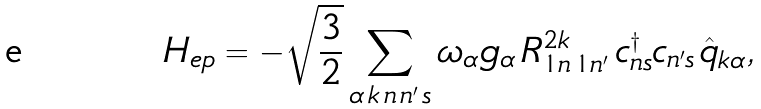<formula> <loc_0><loc_0><loc_500><loc_500>H _ { e p } = - \sqrt { \frac { 3 } { 2 } } \sum _ { \alpha \, k \, n \, n ^ { \prime } \, s } \omega _ { \alpha } g _ { \alpha } \, R ^ { 2 k } _ { 1 n \, 1 n ^ { \prime } } \, c ^ { \dagger } _ { n s } c _ { n ^ { \prime } s } \, \hat { q } _ { k \alpha } ,</formula> 